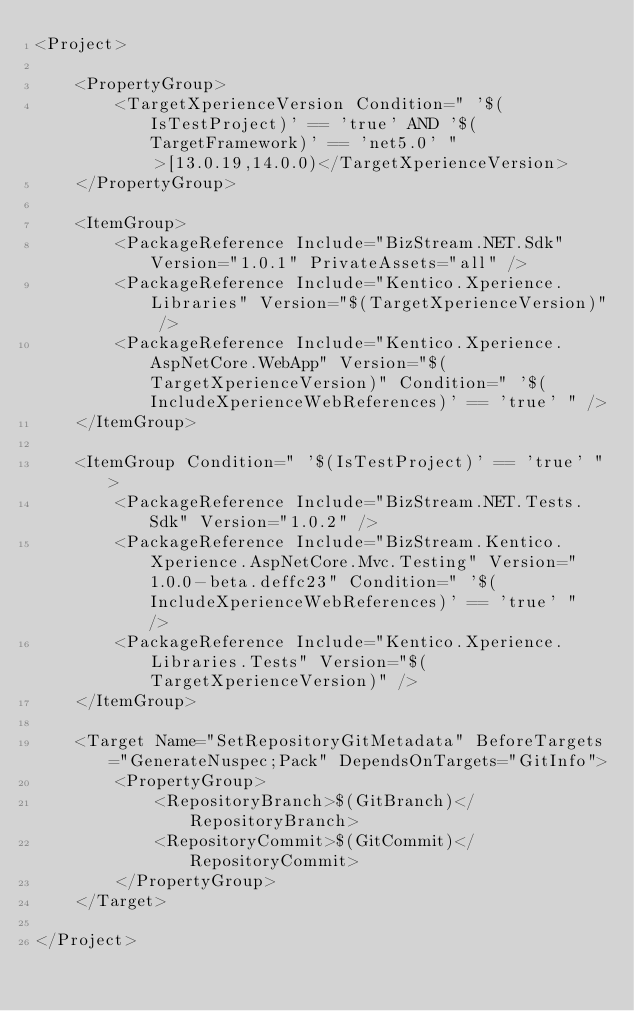Convert code to text. <code><loc_0><loc_0><loc_500><loc_500><_XML_><Project>

    <PropertyGroup>
        <TargetXperienceVersion Condition=" '$(IsTestProject)' == 'true' AND '$(TargetFramework)' == 'net5.0' ">[13.0.19,14.0.0)</TargetXperienceVersion>
    </PropertyGroup>

    <ItemGroup>
        <PackageReference Include="BizStream.NET.Sdk" Version="1.0.1" PrivateAssets="all" />
        <PackageReference Include="Kentico.Xperience.Libraries" Version="$(TargetXperienceVersion)" />
        <PackageReference Include="Kentico.Xperience.AspNetCore.WebApp" Version="$(TargetXperienceVersion)" Condition=" '$(IncludeXperienceWebReferences)' == 'true' " />
    </ItemGroup>

    <ItemGroup Condition=" '$(IsTestProject)' == 'true' ">
        <PackageReference Include="BizStream.NET.Tests.Sdk" Version="1.0.2" />
        <PackageReference Include="BizStream.Kentico.Xperience.AspNetCore.Mvc.Testing" Version="1.0.0-beta.deffc23" Condition=" '$(IncludeXperienceWebReferences)' == 'true' "  />
        <PackageReference Include="Kentico.Xperience.Libraries.Tests" Version="$(TargetXperienceVersion)" />
    </ItemGroup>

    <Target Name="SetRepositoryGitMetadata" BeforeTargets="GenerateNuspec;Pack" DependsOnTargets="GitInfo">
        <PropertyGroup>
            <RepositoryBranch>$(GitBranch)</RepositoryBranch>
            <RepositoryCommit>$(GitCommit)</RepositoryCommit>
        </PropertyGroup>
    </Target>

</Project></code> 